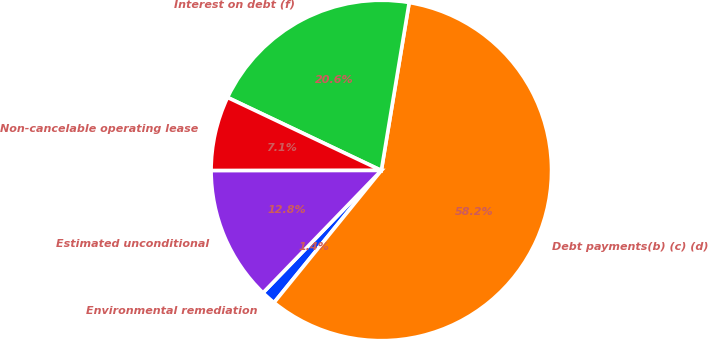Convert chart to OTSL. <chart><loc_0><loc_0><loc_500><loc_500><pie_chart><fcel>Environmental remediation<fcel>Debt payments(b) (c) (d)<fcel>Interest on debt (f)<fcel>Non-cancelable operating lease<fcel>Estimated unconditional<nl><fcel>1.38%<fcel>58.23%<fcel>20.56%<fcel>7.07%<fcel>12.75%<nl></chart> 